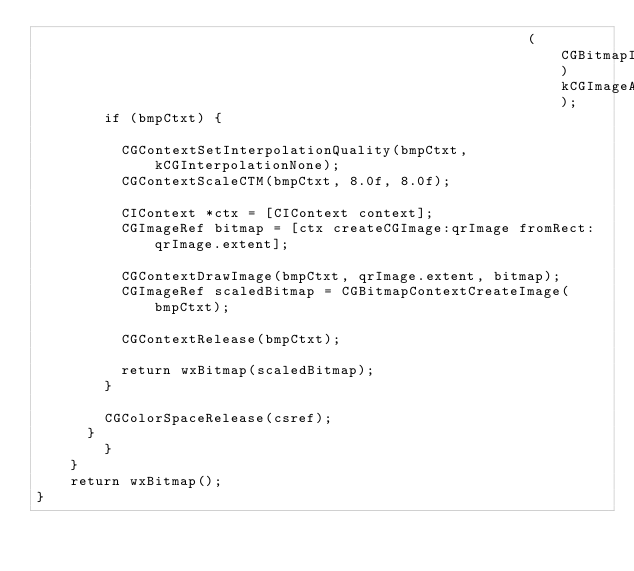Convert code to text. <code><loc_0><loc_0><loc_500><loc_500><_ObjectiveC_>                                                          (CGBitmapInfo)kCGImageAlphaNone);
        if (bmpCtxt) {

          CGContextSetInterpolationQuality(bmpCtxt, kCGInterpolationNone);
          CGContextScaleCTM(bmpCtxt, 8.0f, 8.0f);

          CIContext *ctx = [CIContext context];
          CGImageRef bitmap = [ctx createCGImage:qrImage fromRect:qrImage.extent];

          CGContextDrawImage(bmpCtxt, qrImage.extent, bitmap);
          CGImageRef scaledBitmap = CGBitmapContextCreateImage(bmpCtxt);

          CGContextRelease(bmpCtxt);

          return wxBitmap(scaledBitmap);
        }

        CGColorSpaceRelease(csref);
      }
		}
	}
	return wxBitmap();
}
</code> 